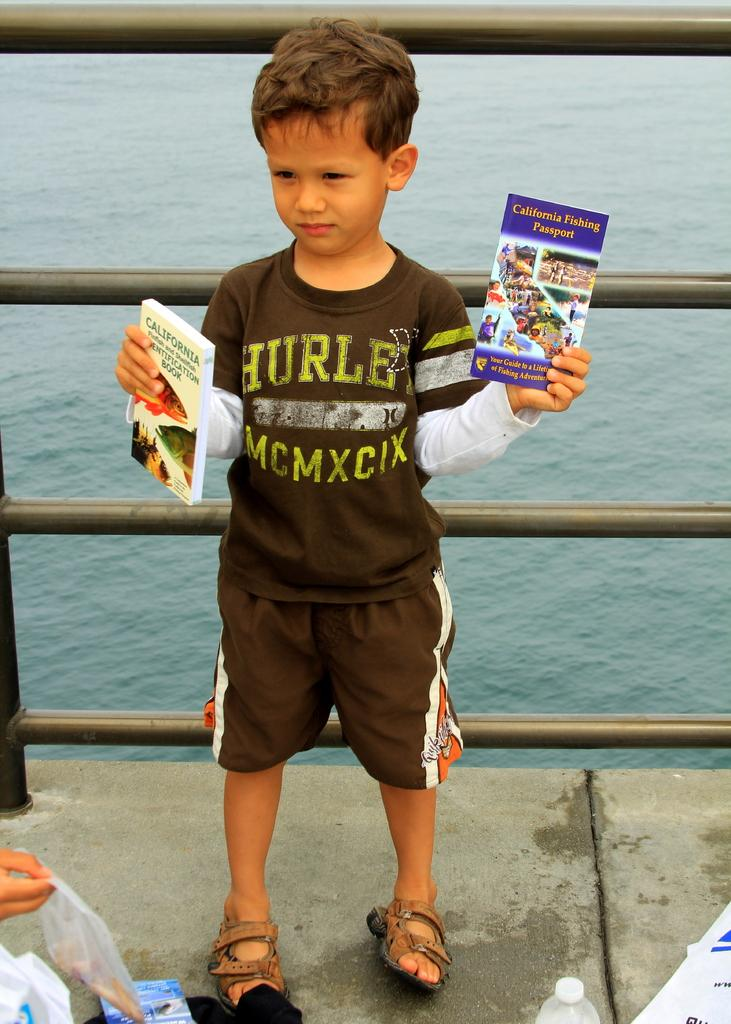Who is the main subject in the image? There is a boy in the image. What is the boy holding in his hands? The boy is holding books in his hands. What type of material is covering the books? There are plastic covers in the image. What else can be seen in the image besides the boy and the books? There is a bottle in the image. What can be seen in the background of the image? There is water visible in the background of the image. What type of roll is the boy using to read the books in the image? There is no roll present in the image; the boy is holding the books with his hands. 